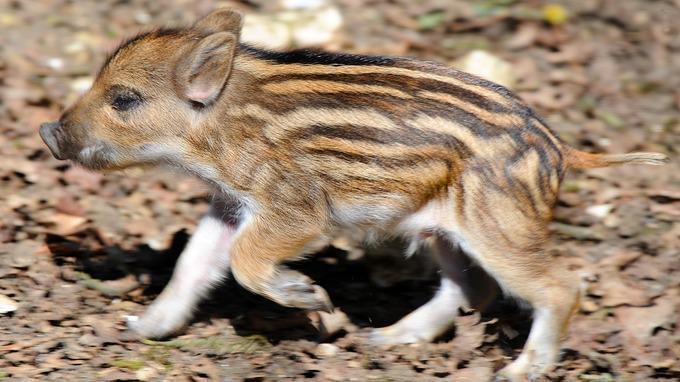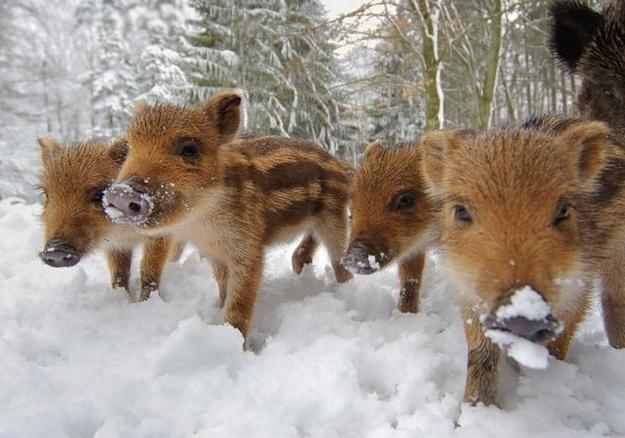The first image is the image on the left, the second image is the image on the right. Assess this claim about the two images: "An image shows just one striped baby wild pig, which is turned leftward and standing on brown ground.". Correct or not? Answer yes or no. Yes. The first image is the image on the left, the second image is the image on the right. For the images shown, is this caption "One of the animals in the image on the left is not striped." true? Answer yes or no. No. 